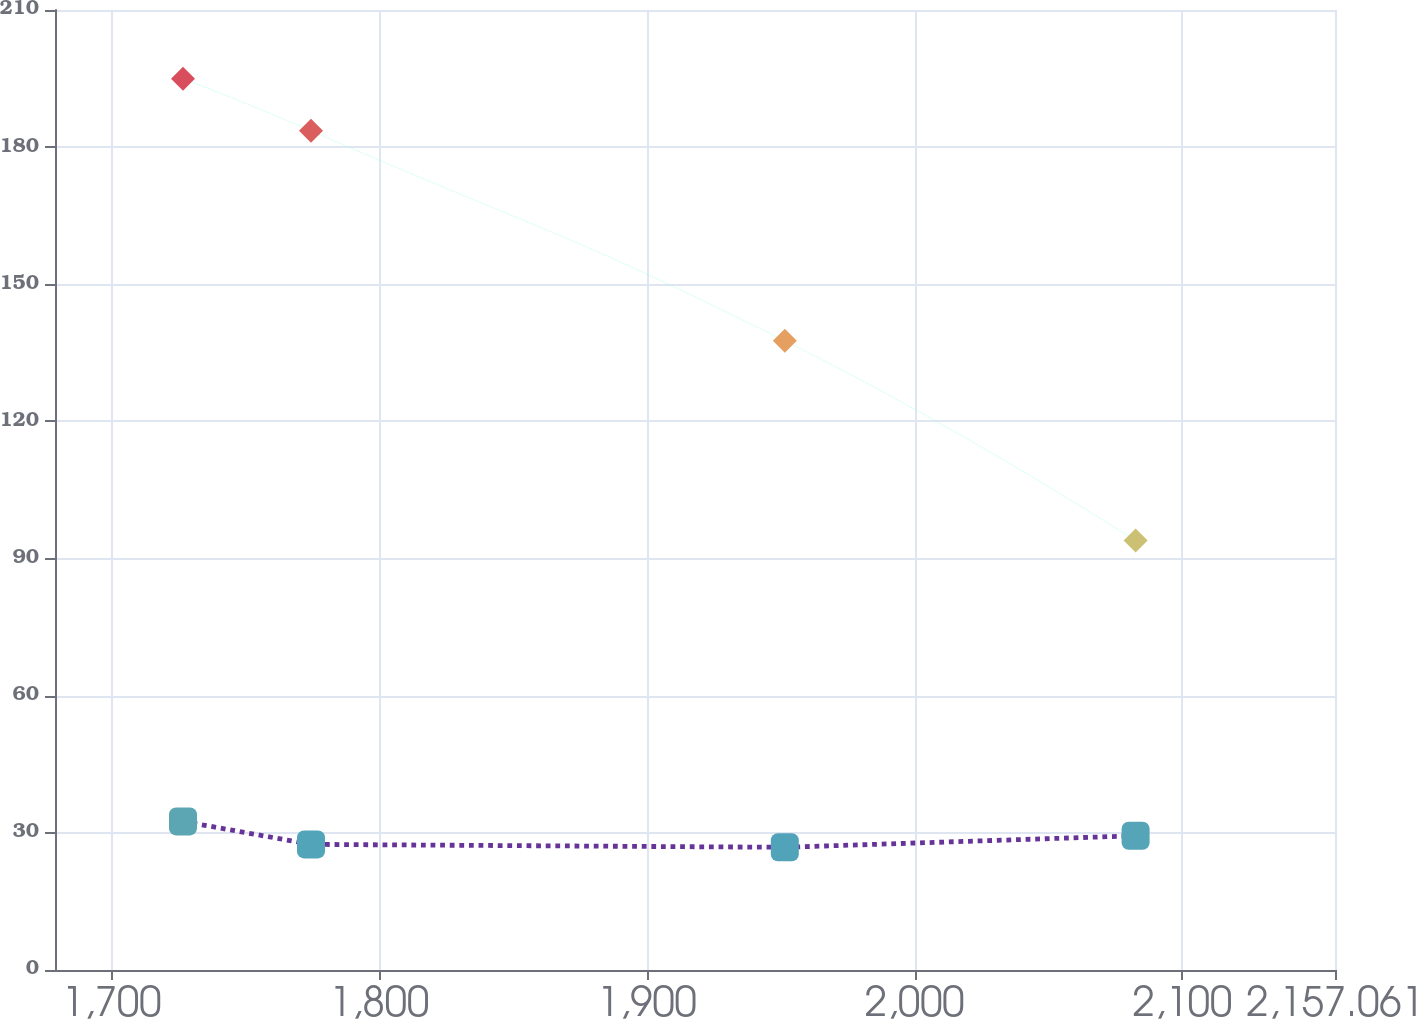<chart> <loc_0><loc_0><loc_500><loc_500><line_chart><ecel><fcel>Operating Lease Obligations<fcel>Capital Lease Obligations<nl><fcel>1726.69<fcel>32.51<fcel>194.98<nl><fcel>1774.51<fcel>27.48<fcel>183.59<nl><fcel>1951.52<fcel>26.84<fcel>137.64<nl><fcel>2082.57<fcel>29.36<fcel>93.93<nl><fcel>2204.88<fcel>26.13<fcel>72.18<nl></chart> 